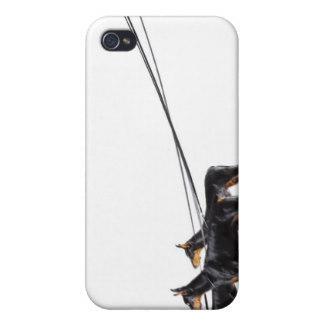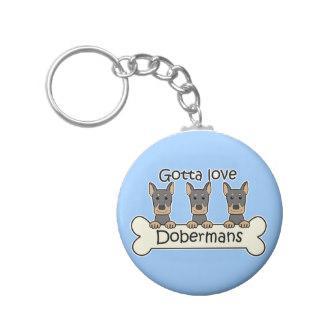The first image is the image on the left, the second image is the image on the right. Considering the images on both sides, is "One image shows a silver keychain featuring a dog theme, and the other image contains a white rectangle with a dog theme." valid? Answer yes or no. Yes. The first image is the image on the left, the second image is the image on the right. Given the left and right images, does the statement "there is a keychain with3 dogs on it" hold true? Answer yes or no. Yes. 